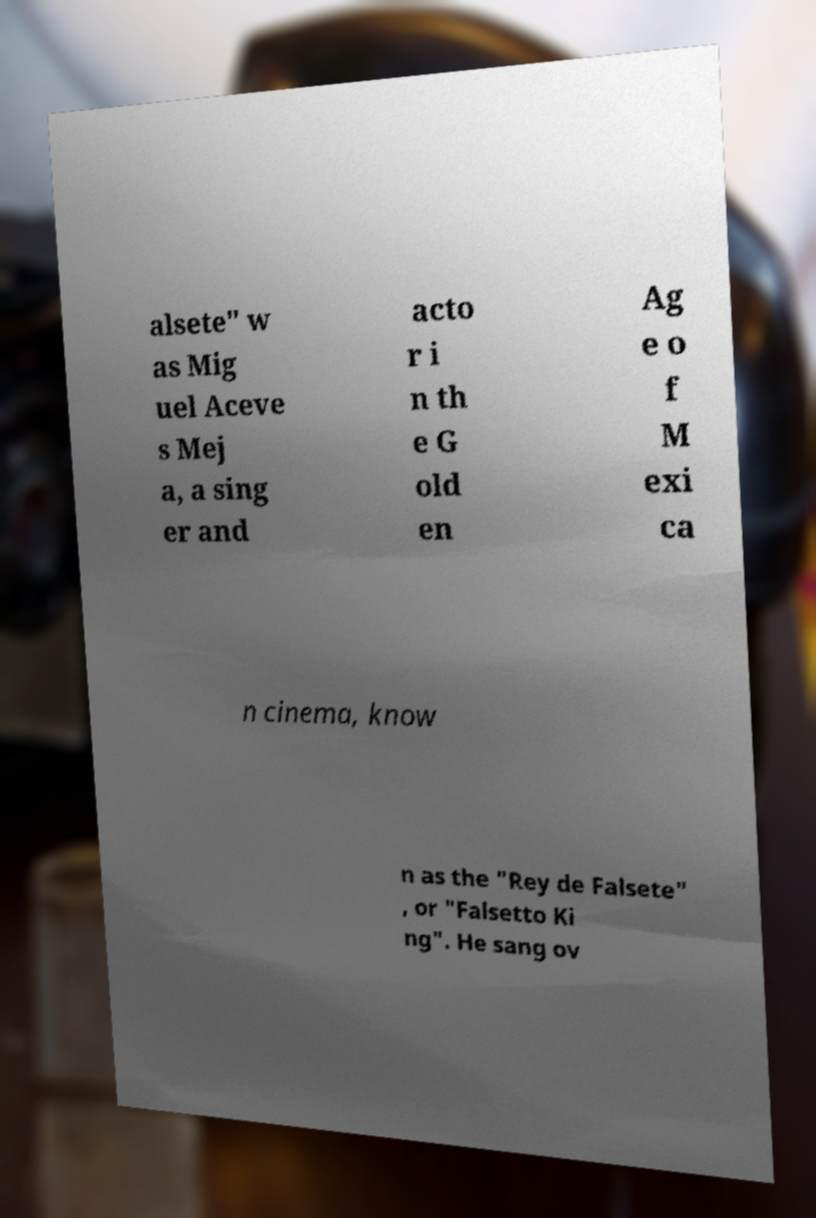Can you accurately transcribe the text from the provided image for me? alsete" w as Mig uel Aceve s Mej a, a sing er and acto r i n th e G old en Ag e o f M exi ca n cinema, know n as the "Rey de Falsete" , or "Falsetto Ki ng". He sang ov 